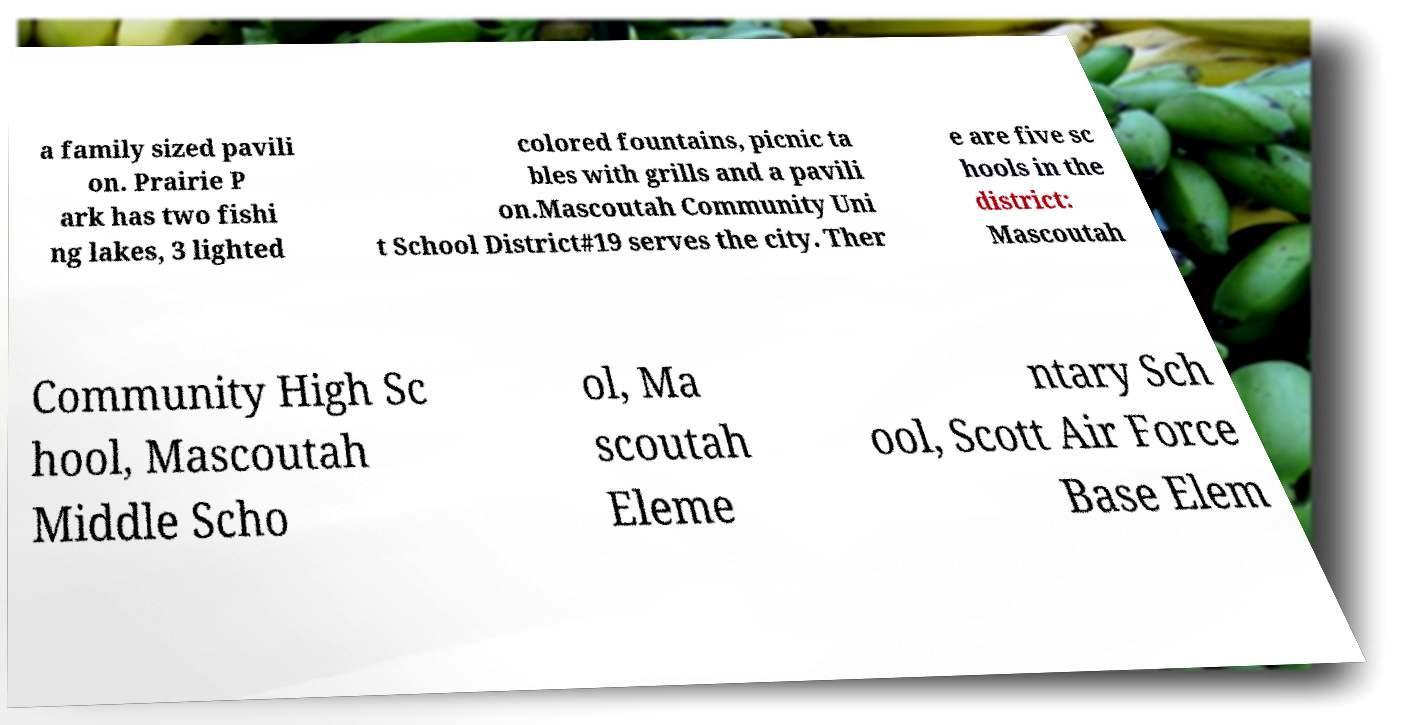Please read and relay the text visible in this image. What does it say? a family sized pavili on. Prairie P ark has two fishi ng lakes, 3 lighted colored fountains, picnic ta bles with grills and a pavili on.Mascoutah Community Uni t School District#19 serves the city. Ther e are five sc hools in the district: Mascoutah Community High Sc hool, Mascoutah Middle Scho ol, Ma scoutah Eleme ntary Sch ool, Scott Air Force Base Elem 